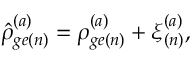Convert formula to latex. <formula><loc_0><loc_0><loc_500><loc_500>\hat { \rho } _ { g e ( n ) } ^ { ( a ) } = \rho _ { g e ( n ) } ^ { ( a ) } + \xi _ { ( n ) } ^ { ( a ) } ,</formula> 